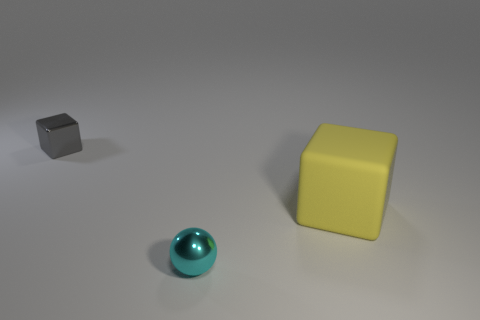Is there any other thing that has the same shape as the small cyan shiny object?
Offer a very short reply. No. Is the size of the metal thing that is right of the gray metallic thing the same as the thing that is on the left side of the cyan thing?
Offer a very short reply. Yes. The thing that is both behind the tiny metallic ball and in front of the tiny gray object is made of what material?
Offer a very short reply. Rubber. Is the number of small green metal cubes less than the number of metal blocks?
Ensure brevity in your answer.  Yes. What is the size of the block right of the metallic thing that is in front of the gray thing?
Your answer should be compact. Large. The thing that is on the left side of the tiny metallic object that is on the right side of the metal thing that is behind the ball is what shape?
Provide a short and direct response. Cube. What is the color of the ball that is the same material as the gray object?
Offer a terse response. Cyan. There is a metal thing behind the tiny cyan sphere that is to the right of the tiny thing to the left of the tiny ball; what is its color?
Keep it short and to the point. Gray. How many cylinders are either small blue rubber things or gray metal objects?
Your answer should be very brief. 0. There is a big block; is it the same color as the tiny metallic thing that is behind the rubber cube?
Provide a succinct answer. No. 